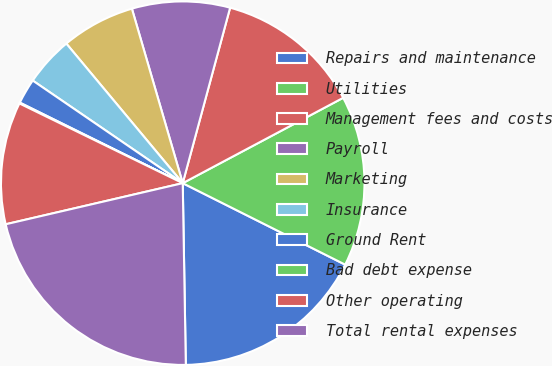<chart> <loc_0><loc_0><loc_500><loc_500><pie_chart><fcel>Repairs and maintenance<fcel>Utilities<fcel>Management fees and costs<fcel>Payroll<fcel>Marketing<fcel>Insurance<fcel>Ground Rent<fcel>Bad debt expense<fcel>Other operating<fcel>Total rental expenses<nl><fcel>17.33%<fcel>15.18%<fcel>13.02%<fcel>8.71%<fcel>6.55%<fcel>4.39%<fcel>2.24%<fcel>0.08%<fcel>10.86%<fcel>21.64%<nl></chart> 